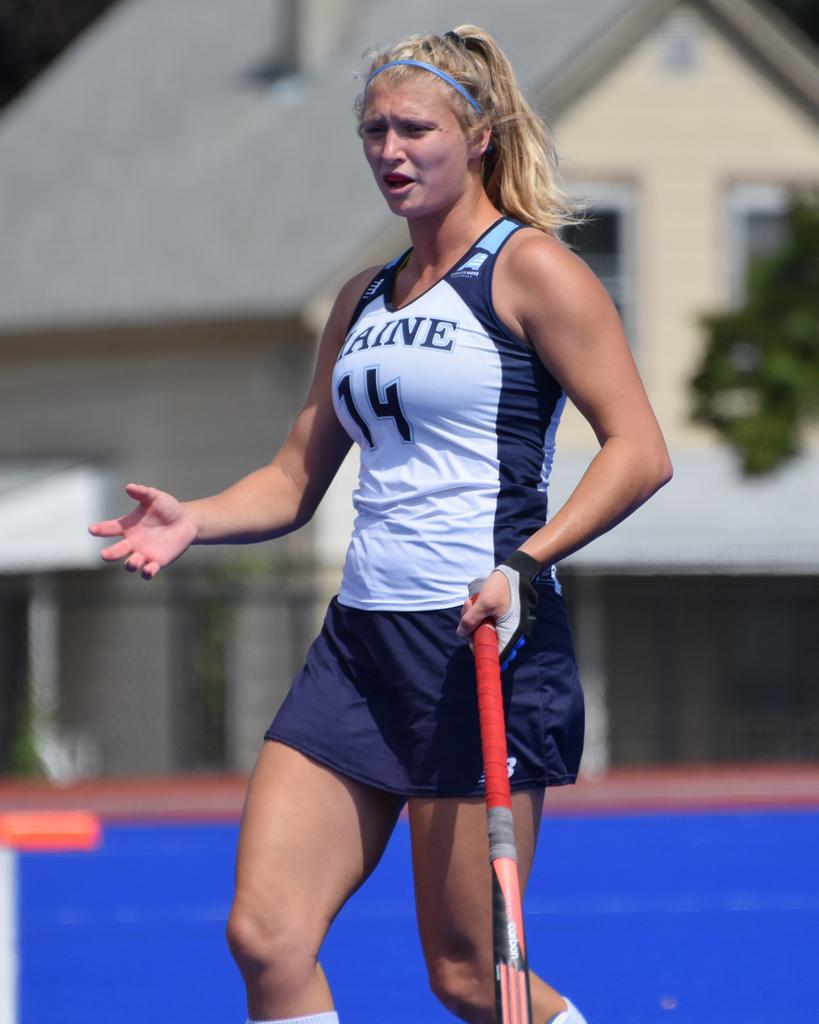<image>
Relay a brief, clear account of the picture shown. A female hockey player wearing the number 14 on her white and blue top stands on the pitch. 